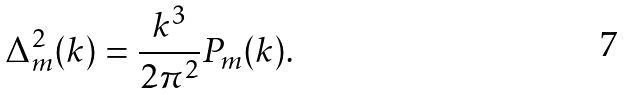Convert formula to latex. <formula><loc_0><loc_0><loc_500><loc_500>\Delta _ { m } ^ { 2 } ( k ) = \frac { k ^ { 3 } } { 2 \pi ^ { 2 } } P _ { m } ( k ) .</formula> 